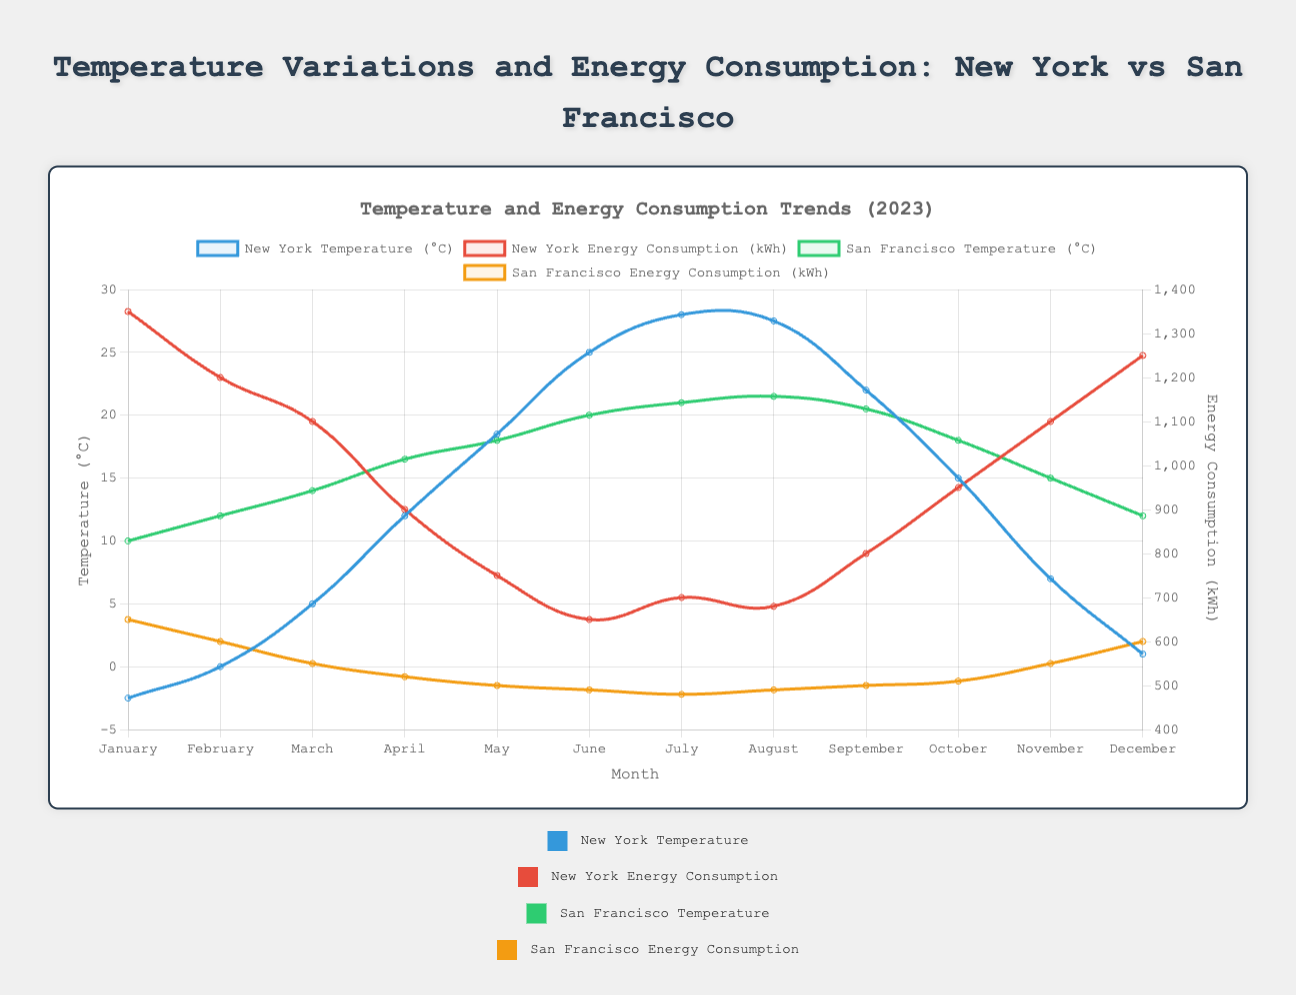What's the difference in energy consumption between the coldest month and the hottest month in New York? The coldest month in New York is January with an energy consumption of 1350 kWh, and the hottest month is July with an energy consumption of 700 kWh. The difference is 1350 kWh - 700 kWh.
Answer: 650 kWh Which month shows the steepest decrease in energy consumption in New York? From March to April, energy consumption decreases from 1100 kWh to 900 kWh, which is a decrease of 200 kWh. This is the steepest decrease.
Answer: April During which month is the energy consumption the highest in San Francisco? The highest energy consumption in San Francisco is in January, with a consumption of 650 kWh.
Answer: January What is the average temperature across the 12 months in San Francisco? Sum the average temperatures of San Francisco for all 12 months and divide by 12: (10 + 12 + 14 + 16.5 + 18 + 20 + 21 + 21.5 + 20.5 + 18 + 15 + 12) / 12. This gives 188.5 / 12 = 15.71°C.
Answer: 15.71°C Compare the energy consumption trends in summer between New York and San Francisco. In New York, the energy consumption decreases from June (650 kWh) to August (680 kWh). In contrast, energy consumption in San Francisco is relatively stable, changing from 490 kWh in June to 490 kWh in August.
Answer: NY decreases, SF stable Which city shows a higher increase in temperature from January to June? New York's temperature increases from -2.5°C to 25°C, an increase of 27.5°C. San Francisco's temperature increases from 10°C to 20°C, an increase of 10°C. Therefore, New York shows a higher increase.
Answer: New York In which month does New York experience the sharpest increase in temperature? The sharpest increase occurs from March to April, going from 5°C to 12°C, an increase of 7°C.
Answer: April What is the range of energy consumption in San Francisco over the year? The highest energy consumption in San Francisco is 650 kWh (January), and the lowest is 480 kWh (July). The range is 650 kWh - 480 kWh.
Answer: 170 kWh Which city shows a more significant difference in energy consumption between January and December? In New York, energy consumption is 1350 kWh in January and 1250 kWh in December (difference is 100 kWh). In San Francisco, it is 650 kWh in January and 600 kWh in December (difference is 50 kWh). Therefore, New York shows a more significant difference.
Answer: New York In which months does San Francisco maintain a relatively stable temperature? San Francisco maintains a relatively stable temperature from July to September, with temperatures between 20.5°C and 21.5°C.
Answer: July to September 